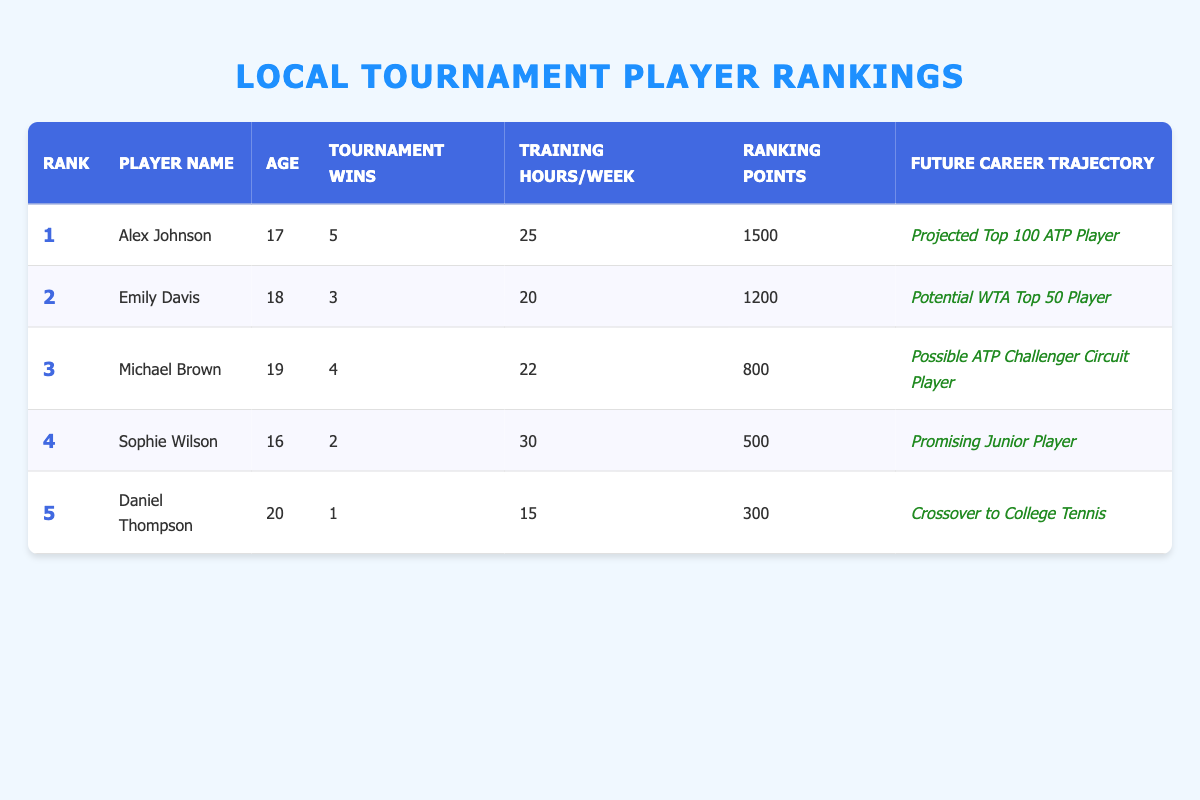What is the age of Emily Davis? Emily Davis's age is directly listed in the table, under the Age column corresponding to her entry.
Answer: 18 How many tournament wins does Alex Johnson have? Alex Johnson's tournament wins are clearly indicated in the table, found in the Tournament Wins column associated with his name.
Answer: 5 Which player has the highest current ranking points? To find the player with the highest current ranking points, we compare the values in the Current Ranking Points column. Alex Johnson has the most points at 1500.
Answer: Alex Johnson Is Sophie Wilson younger than Daniel Thompson? The ages of both players are compared from the Age column. Sophie Wilson is 16, while Daniel Thompson is 20, thus confirming she is younger.
Answer: Yes What is the average training hours per week of the top three ranked players? We sum the training hours of the top three players: Alex Johnson (25) + Emily Davis (20) + Michael Brown (22) = 67. Then, we divide by 3 to find the average: 67/3 = 22.33.
Answer: 22.33 Which player has the lowest future career trajectory ranking? Analyzing the Future Career Trajectory column, we note that Daniel Thompson's trajectory is described as "Crossover to College Tennis," which is ranked lower than the others that suggest higher professional paths.
Answer: Daniel Thompson What is the total number of tournament wins for the top four players? The total can be derived by summing up the Tournament Wins for the first four players: 5 (Alex Johnson) + 3 (Emily Davis) + 4 (Michael Brown) + 2 (Sophie Wilson) = 14.
Answer: 14 Does Michael Brown have more training hours per week than Daniel Thompson? Comparing the Training Hours/Week columns, Michael Brown has 22 hours while Daniel Thompson has 15 hours, confirming that Michael has more.
Answer: Yes What is the future career trajectory of the youngest player? We first identify the youngest player from the Age column; that is Sophie Wilson at 16. We then read her Future Career Trajectory entry, confirming it as "Promising Junior Player."
Answer: Promising Junior Player Is there any player with more than two tournament wins who is projected as a top 100 player? We check each player's tournament wins and their career trajectory. Alex Johnson has 5 wins and is projected as a Top 100 ATP Player. Thus, the criteria are met.
Answer: Yes 